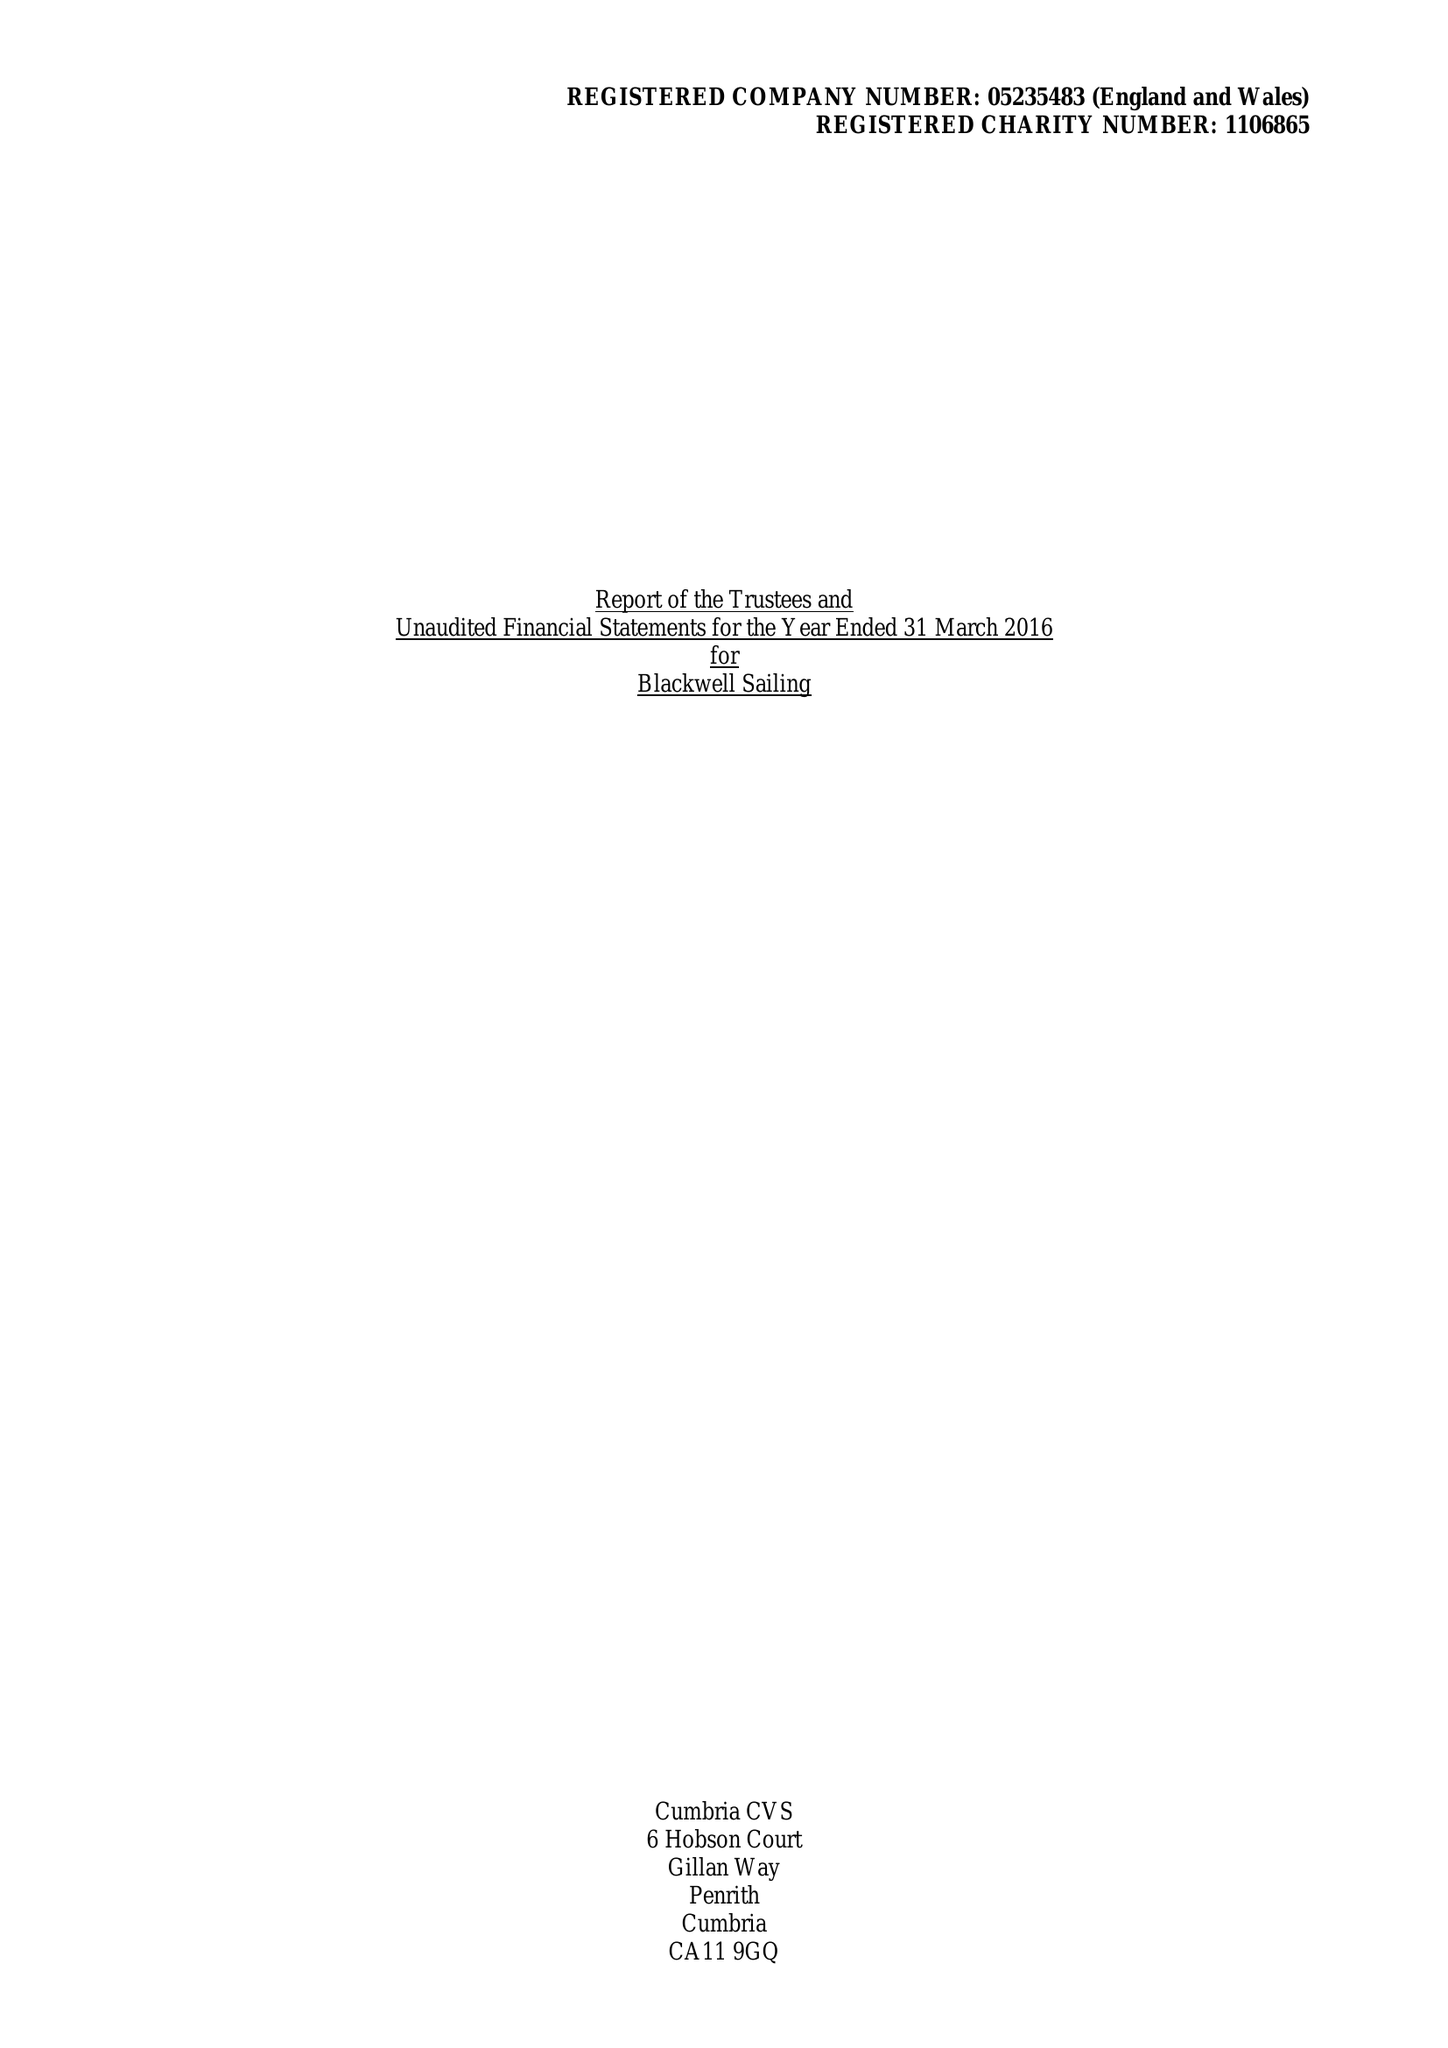What is the value for the charity_number?
Answer the question using a single word or phrase. 1106865 